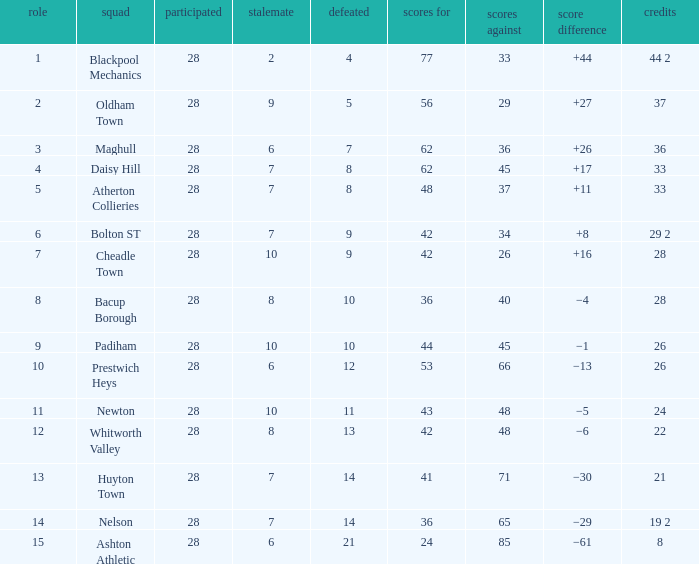What is the average played for entries with fewer than 65 goals against, points 1 of 19 2, and a position higher than 15? None. 